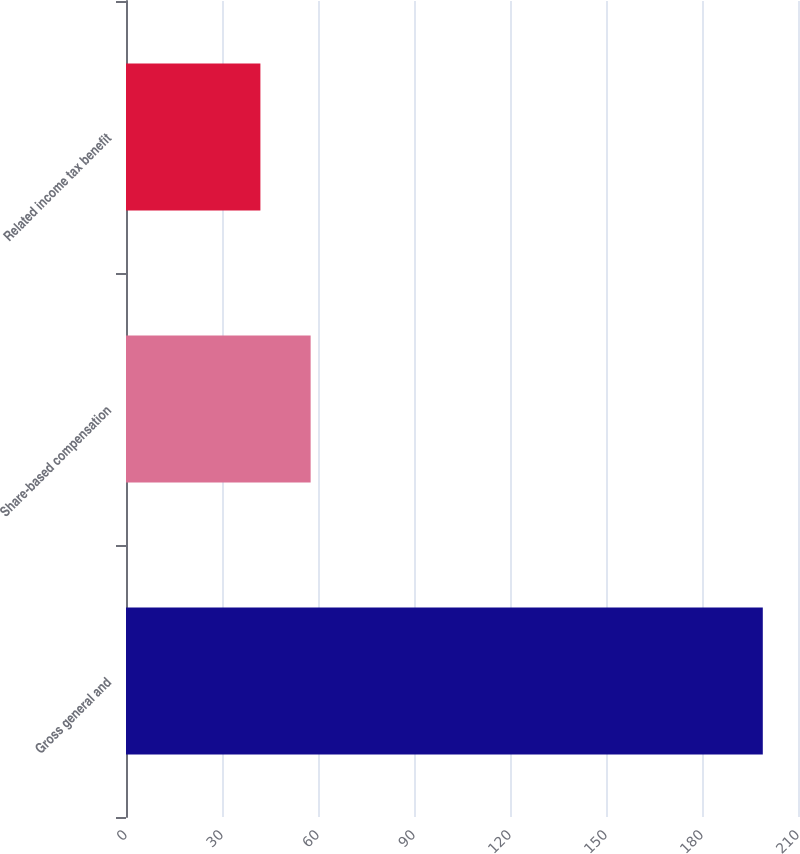Convert chart. <chart><loc_0><loc_0><loc_500><loc_500><bar_chart><fcel>Gross general and<fcel>Share-based compensation<fcel>Related income tax benefit<nl><fcel>199<fcel>57.7<fcel>42<nl></chart> 